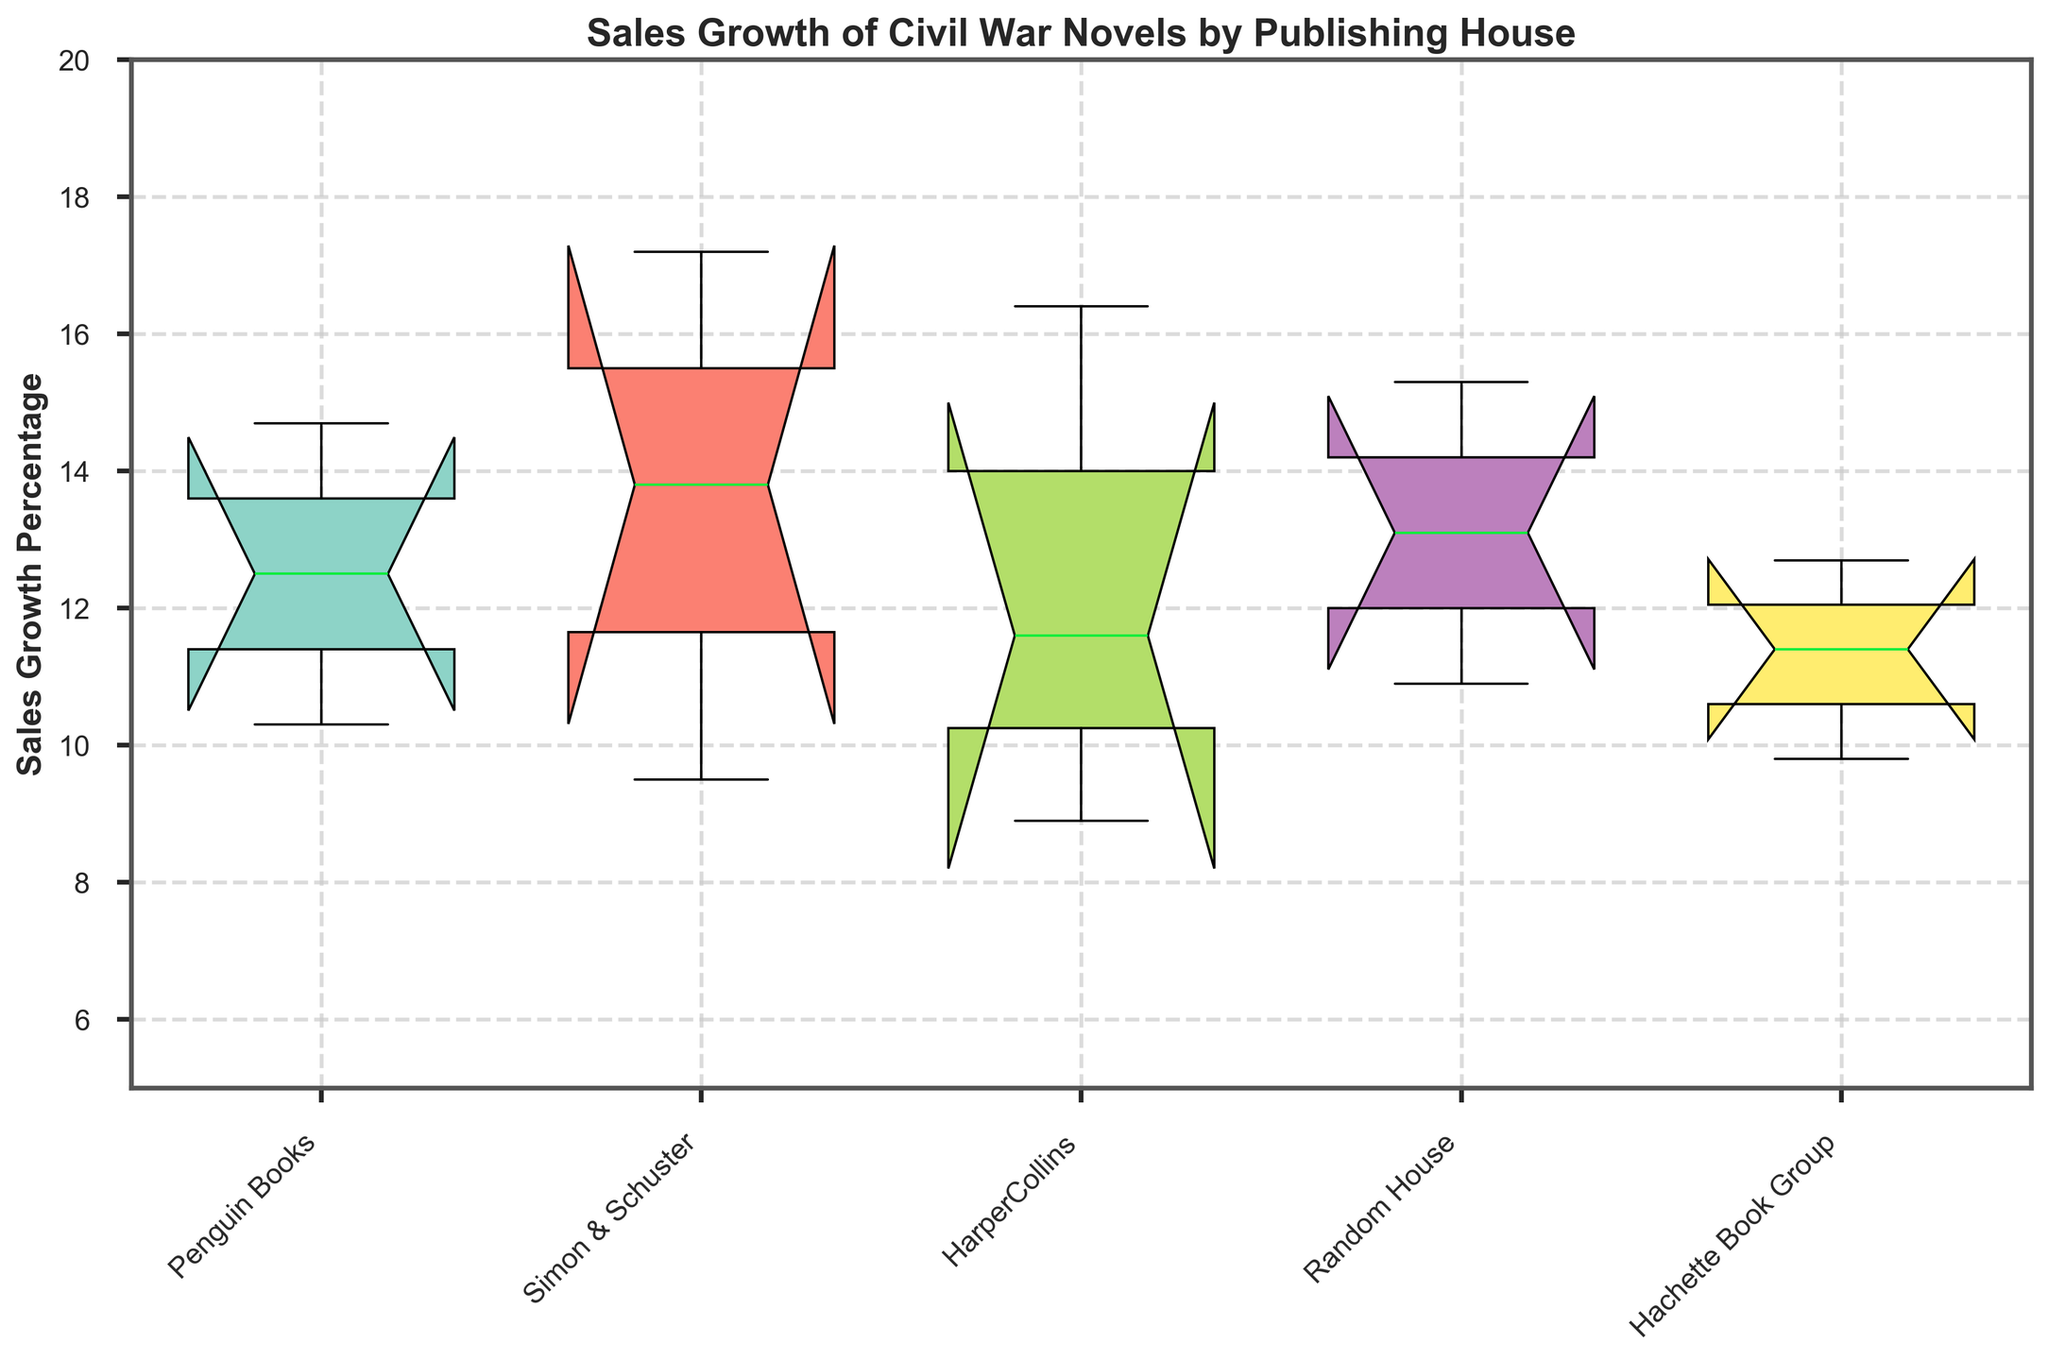Which publishing house has the highest median sales growth percentage? To determine this, observe the notched sections of the boxes. The highest median is where the notch is the highest.
Answer: Simon & Schuster What range of sales growth percentage does Random House cover? The range spans from the minimum value at the bottom whisker to the maximum value at the top whisker for Random House.
Answer: 10.9% to 15.3% How does Penguin Books compare with Simon & Schuster in terms of the median sales growth percentage? To compare, look at the median line within the boxes for both publishers and see which one is higher.
Answer: Simon & Schuster > Penguin Books Which publishing house has the smallest range of sales growth percentage? Look at the total length of the whiskers for each publishing house. The smallest range is the shortest whisker span.
Answer: HarperCollins Is there any overlap in the distribution of sales growth percentages between Hachette Book Group and Random House? To check for overlap, see if the notches of the boxes intersect. If they do, then there is overlap.
Answer: Yes Which publishing house has the widest interquartile range (IQR) of sales growth percentage? The IQR is the distance between the top and bottom of the box. The publisher with the widest IQR has the tallest box.
Answer: Penguin Books What is the lowest sales growth percentage recorded for HarperCollins? The lowest value is represented by the bottom point of the whisker for HarperCollins.
Answer: 8.9% Which publishing house has the highest maximum sales growth percentage? Find the highest point of the whiskers among all publishing houses.
Answer: Simon & Schuster Are there any outliers in the sales growth percentages for Random House? Outliers would be shown as dots outside the whiskers, check if there are any such dots for Random House.
Answer: No What is the approximate median sales growth percentage for Hachette Book Group? Find the middle line within the box of Hachette Book Group; this represents the median.
Answer: Approximately 11.4% 